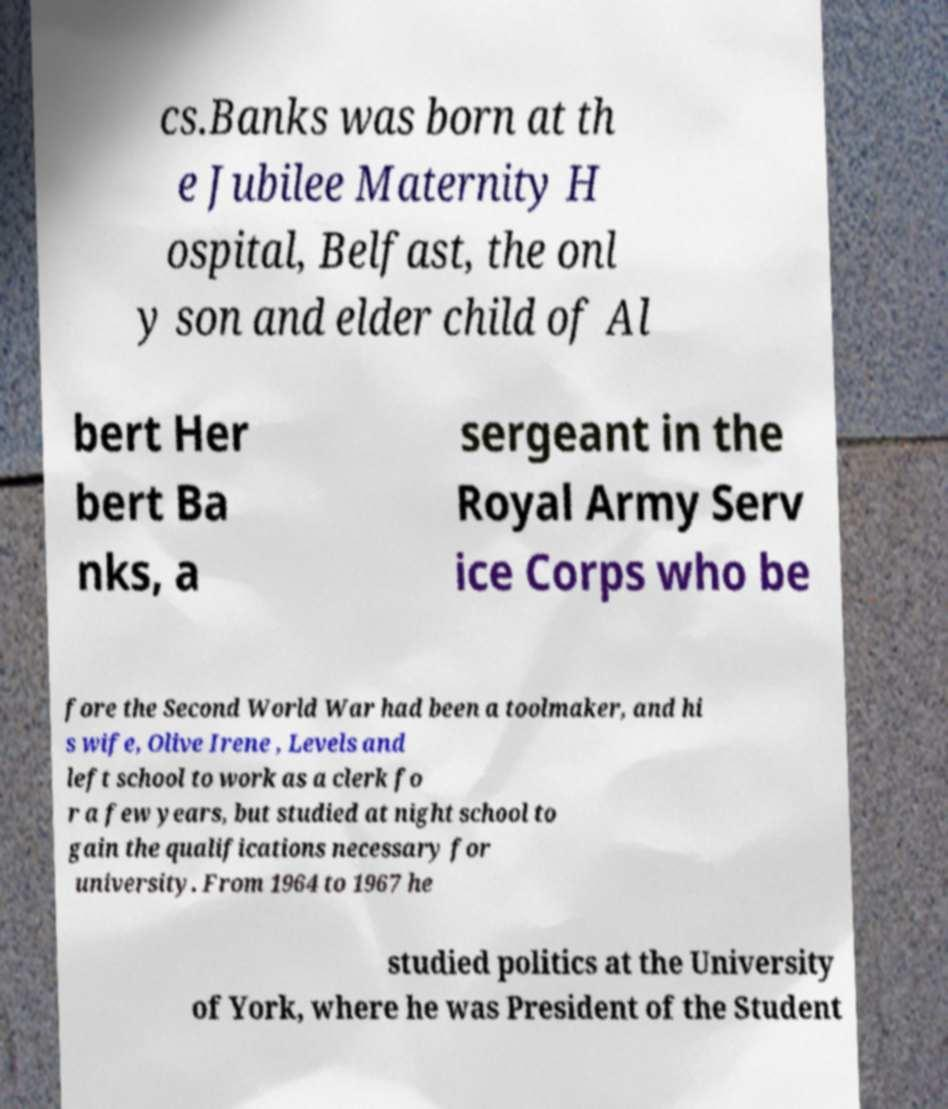Please read and relay the text visible in this image. What does it say? cs.Banks was born at th e Jubilee Maternity H ospital, Belfast, the onl y son and elder child of Al bert Her bert Ba nks, a sergeant in the Royal Army Serv ice Corps who be fore the Second World War had been a toolmaker, and hi s wife, Olive Irene , Levels and left school to work as a clerk fo r a few years, but studied at night school to gain the qualifications necessary for university. From 1964 to 1967 he studied politics at the University of York, where he was President of the Student 